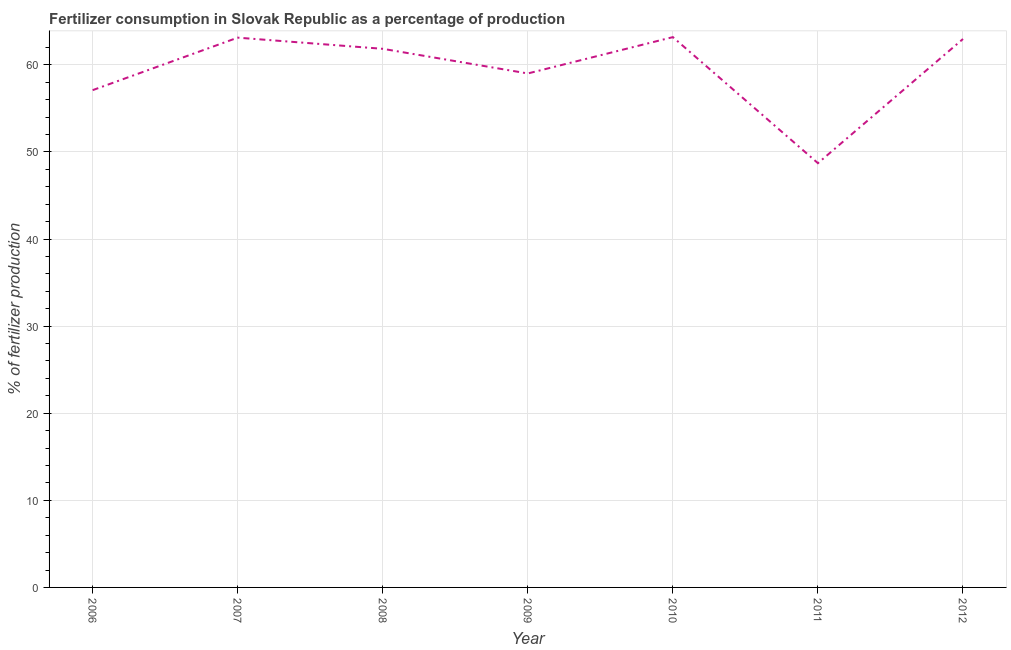What is the amount of fertilizer consumption in 2011?
Your answer should be very brief. 48.72. Across all years, what is the maximum amount of fertilizer consumption?
Provide a short and direct response. 63.19. Across all years, what is the minimum amount of fertilizer consumption?
Offer a very short reply. 48.72. In which year was the amount of fertilizer consumption maximum?
Your response must be concise. 2010. In which year was the amount of fertilizer consumption minimum?
Offer a terse response. 2011. What is the sum of the amount of fertilizer consumption?
Provide a short and direct response. 415.96. What is the difference between the amount of fertilizer consumption in 2006 and 2012?
Offer a very short reply. -5.87. What is the average amount of fertilizer consumption per year?
Your answer should be very brief. 59.42. What is the median amount of fertilizer consumption?
Offer a terse response. 61.84. Do a majority of the years between 2006 and 2011 (inclusive) have amount of fertilizer consumption greater than 14 %?
Offer a terse response. Yes. What is the ratio of the amount of fertilizer consumption in 2006 to that in 2009?
Keep it short and to the point. 0.97. Is the difference between the amount of fertilizer consumption in 2007 and 2009 greater than the difference between any two years?
Make the answer very short. No. What is the difference between the highest and the second highest amount of fertilizer consumption?
Your answer should be compact. 0.06. Is the sum of the amount of fertilizer consumption in 2006 and 2012 greater than the maximum amount of fertilizer consumption across all years?
Offer a very short reply. Yes. What is the difference between the highest and the lowest amount of fertilizer consumption?
Keep it short and to the point. 14.47. Does the amount of fertilizer consumption monotonically increase over the years?
Provide a succinct answer. No. How many lines are there?
Your answer should be very brief. 1. What is the difference between two consecutive major ticks on the Y-axis?
Your response must be concise. 10. Are the values on the major ticks of Y-axis written in scientific E-notation?
Your answer should be compact. No. Does the graph contain any zero values?
Give a very brief answer. No. Does the graph contain grids?
Your answer should be very brief. Yes. What is the title of the graph?
Ensure brevity in your answer.  Fertilizer consumption in Slovak Republic as a percentage of production. What is the label or title of the Y-axis?
Keep it short and to the point. % of fertilizer production. What is the % of fertilizer production in 2006?
Offer a very short reply. 57.1. What is the % of fertilizer production of 2007?
Keep it short and to the point. 63.13. What is the % of fertilizer production of 2008?
Make the answer very short. 61.84. What is the % of fertilizer production of 2009?
Your response must be concise. 59.02. What is the % of fertilizer production in 2010?
Offer a terse response. 63.19. What is the % of fertilizer production of 2011?
Make the answer very short. 48.72. What is the % of fertilizer production of 2012?
Your answer should be very brief. 62.97. What is the difference between the % of fertilizer production in 2006 and 2007?
Provide a short and direct response. -6.03. What is the difference between the % of fertilizer production in 2006 and 2008?
Ensure brevity in your answer.  -4.75. What is the difference between the % of fertilizer production in 2006 and 2009?
Ensure brevity in your answer.  -1.92. What is the difference between the % of fertilizer production in 2006 and 2010?
Offer a very short reply. -6.09. What is the difference between the % of fertilizer production in 2006 and 2011?
Give a very brief answer. 8.38. What is the difference between the % of fertilizer production in 2006 and 2012?
Make the answer very short. -5.87. What is the difference between the % of fertilizer production in 2007 and 2008?
Your answer should be very brief. 1.28. What is the difference between the % of fertilizer production in 2007 and 2009?
Give a very brief answer. 4.11. What is the difference between the % of fertilizer production in 2007 and 2010?
Your answer should be very brief. -0.06. What is the difference between the % of fertilizer production in 2007 and 2011?
Keep it short and to the point. 14.41. What is the difference between the % of fertilizer production in 2007 and 2012?
Provide a succinct answer. 0.15. What is the difference between the % of fertilizer production in 2008 and 2009?
Give a very brief answer. 2.83. What is the difference between the % of fertilizer production in 2008 and 2010?
Your answer should be compact. -1.34. What is the difference between the % of fertilizer production in 2008 and 2011?
Your response must be concise. 13.13. What is the difference between the % of fertilizer production in 2008 and 2012?
Give a very brief answer. -1.13. What is the difference between the % of fertilizer production in 2009 and 2010?
Make the answer very short. -4.17. What is the difference between the % of fertilizer production in 2009 and 2011?
Provide a short and direct response. 10.3. What is the difference between the % of fertilizer production in 2009 and 2012?
Ensure brevity in your answer.  -3.96. What is the difference between the % of fertilizer production in 2010 and 2011?
Your answer should be very brief. 14.47. What is the difference between the % of fertilizer production in 2010 and 2012?
Keep it short and to the point. 0.21. What is the difference between the % of fertilizer production in 2011 and 2012?
Your answer should be compact. -14.26. What is the ratio of the % of fertilizer production in 2006 to that in 2007?
Keep it short and to the point. 0.91. What is the ratio of the % of fertilizer production in 2006 to that in 2008?
Your response must be concise. 0.92. What is the ratio of the % of fertilizer production in 2006 to that in 2009?
Ensure brevity in your answer.  0.97. What is the ratio of the % of fertilizer production in 2006 to that in 2010?
Your answer should be very brief. 0.9. What is the ratio of the % of fertilizer production in 2006 to that in 2011?
Your response must be concise. 1.17. What is the ratio of the % of fertilizer production in 2006 to that in 2012?
Your response must be concise. 0.91. What is the ratio of the % of fertilizer production in 2007 to that in 2008?
Your answer should be very brief. 1.02. What is the ratio of the % of fertilizer production in 2007 to that in 2009?
Ensure brevity in your answer.  1.07. What is the ratio of the % of fertilizer production in 2007 to that in 2010?
Provide a succinct answer. 1. What is the ratio of the % of fertilizer production in 2007 to that in 2011?
Keep it short and to the point. 1.3. What is the ratio of the % of fertilizer production in 2008 to that in 2009?
Ensure brevity in your answer.  1.05. What is the ratio of the % of fertilizer production in 2008 to that in 2010?
Make the answer very short. 0.98. What is the ratio of the % of fertilizer production in 2008 to that in 2011?
Your answer should be compact. 1.27. What is the ratio of the % of fertilizer production in 2009 to that in 2010?
Give a very brief answer. 0.93. What is the ratio of the % of fertilizer production in 2009 to that in 2011?
Offer a very short reply. 1.21. What is the ratio of the % of fertilizer production in 2009 to that in 2012?
Provide a succinct answer. 0.94. What is the ratio of the % of fertilizer production in 2010 to that in 2011?
Make the answer very short. 1.3. What is the ratio of the % of fertilizer production in 2011 to that in 2012?
Your answer should be very brief. 0.77. 